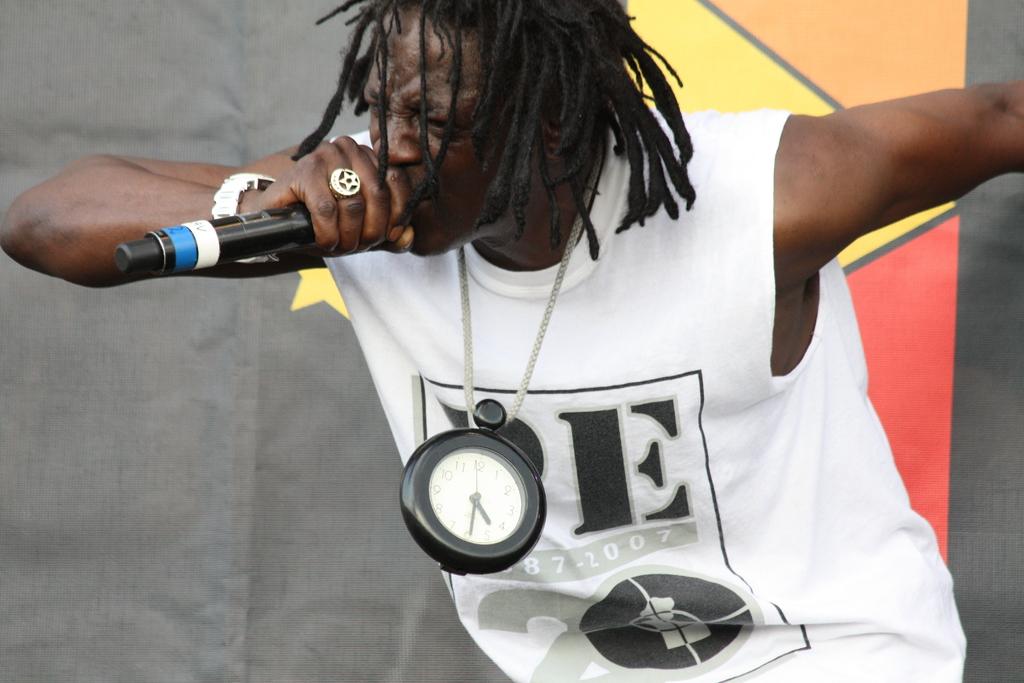What is the time shown on the clock?
Your answer should be very brief. 5:30. What letters are on the musician's shirt?
Provide a succinct answer. E. 